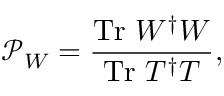Convert formula to latex. <formula><loc_0><loc_0><loc_500><loc_500>\mathcal { P } _ { W } = \frac { T r W ^ { \dagger } W } { T r T ^ { \dagger } T } ,</formula> 